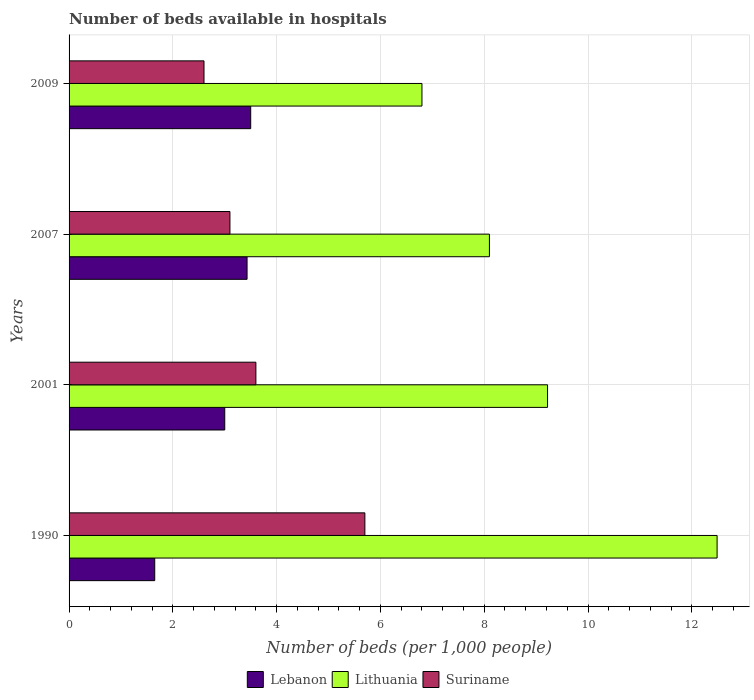How many different coloured bars are there?
Provide a short and direct response. 3. Are the number of bars per tick equal to the number of legend labels?
Your answer should be very brief. Yes. Are the number of bars on each tick of the Y-axis equal?
Offer a very short reply. Yes. How many bars are there on the 3rd tick from the top?
Offer a terse response. 3. What is the number of beds in the hospiatls of in Lebanon in 1990?
Your response must be concise. 1.65. Across all years, what is the maximum number of beds in the hospiatls of in Suriname?
Offer a very short reply. 5.7. Across all years, what is the minimum number of beds in the hospiatls of in Lebanon?
Ensure brevity in your answer.  1.65. In which year was the number of beds in the hospiatls of in Lithuania maximum?
Offer a very short reply. 1990. What is the total number of beds in the hospiatls of in Lebanon in the graph?
Make the answer very short. 11.58. What is the difference between the number of beds in the hospiatls of in Lithuania in 2001 and that in 2007?
Provide a succinct answer. 1.12. What is the difference between the number of beds in the hospiatls of in Lithuania in 1990 and the number of beds in the hospiatls of in Lebanon in 2001?
Make the answer very short. 9.49. What is the average number of beds in the hospiatls of in Lithuania per year?
Offer a terse response. 9.15. In the year 2007, what is the difference between the number of beds in the hospiatls of in Suriname and number of beds in the hospiatls of in Lebanon?
Your response must be concise. -0.33. In how many years, is the number of beds in the hospiatls of in Lebanon greater than 2.8 ?
Offer a very short reply. 3. What is the ratio of the number of beds in the hospiatls of in Lebanon in 2007 to that in 2009?
Give a very brief answer. 0.98. Is the number of beds in the hospiatls of in Lebanon in 2001 less than that in 2007?
Provide a short and direct response. Yes. Is the difference between the number of beds in the hospiatls of in Suriname in 1990 and 2001 greater than the difference between the number of beds in the hospiatls of in Lebanon in 1990 and 2001?
Your response must be concise. Yes. What is the difference between the highest and the second highest number of beds in the hospiatls of in Suriname?
Offer a terse response. 2.1. What is the difference between the highest and the lowest number of beds in the hospiatls of in Lebanon?
Offer a very short reply. 1.85. In how many years, is the number of beds in the hospiatls of in Lebanon greater than the average number of beds in the hospiatls of in Lebanon taken over all years?
Your answer should be very brief. 3. What does the 2nd bar from the top in 1990 represents?
Your answer should be compact. Lithuania. What does the 3rd bar from the bottom in 1990 represents?
Ensure brevity in your answer.  Suriname. Are all the bars in the graph horizontal?
Offer a very short reply. Yes. How many years are there in the graph?
Offer a terse response. 4. What is the difference between two consecutive major ticks on the X-axis?
Your answer should be very brief. 2. Does the graph contain any zero values?
Give a very brief answer. No. Does the graph contain grids?
Give a very brief answer. Yes. Where does the legend appear in the graph?
Make the answer very short. Bottom center. How many legend labels are there?
Your answer should be very brief. 3. How are the legend labels stacked?
Your response must be concise. Horizontal. What is the title of the graph?
Provide a short and direct response. Number of beds available in hospitals. Does "Bermuda" appear as one of the legend labels in the graph?
Make the answer very short. No. What is the label or title of the X-axis?
Your response must be concise. Number of beds (per 1,0 people). What is the Number of beds (per 1,000 people) of Lebanon in 1990?
Offer a very short reply. 1.65. What is the Number of beds (per 1,000 people) of Lithuania in 1990?
Your answer should be very brief. 12.49. What is the Number of beds (per 1,000 people) of Suriname in 1990?
Give a very brief answer. 5.7. What is the Number of beds (per 1,000 people) of Lebanon in 2001?
Make the answer very short. 3. What is the Number of beds (per 1,000 people) of Lithuania in 2001?
Keep it short and to the point. 9.22. What is the Number of beds (per 1,000 people) in Suriname in 2001?
Your response must be concise. 3.6. What is the Number of beds (per 1,000 people) of Lebanon in 2007?
Keep it short and to the point. 3.43. Across all years, what is the maximum Number of beds (per 1,000 people) in Lebanon?
Offer a terse response. 3.5. Across all years, what is the maximum Number of beds (per 1,000 people) in Lithuania?
Make the answer very short. 12.49. Across all years, what is the maximum Number of beds (per 1,000 people) in Suriname?
Your answer should be very brief. 5.7. Across all years, what is the minimum Number of beds (per 1,000 people) in Lebanon?
Your answer should be very brief. 1.65. Across all years, what is the minimum Number of beds (per 1,000 people) in Lithuania?
Ensure brevity in your answer.  6.8. Across all years, what is the minimum Number of beds (per 1,000 people) of Suriname?
Make the answer very short. 2.6. What is the total Number of beds (per 1,000 people) in Lebanon in the graph?
Make the answer very short. 11.58. What is the total Number of beds (per 1,000 people) of Lithuania in the graph?
Give a very brief answer. 36.61. What is the total Number of beds (per 1,000 people) in Suriname in the graph?
Your answer should be compact. 15. What is the difference between the Number of beds (per 1,000 people) of Lebanon in 1990 and that in 2001?
Your response must be concise. -1.35. What is the difference between the Number of beds (per 1,000 people) of Lithuania in 1990 and that in 2001?
Your response must be concise. 3.27. What is the difference between the Number of beds (per 1,000 people) of Lebanon in 1990 and that in 2007?
Provide a short and direct response. -1.78. What is the difference between the Number of beds (per 1,000 people) in Lithuania in 1990 and that in 2007?
Offer a very short reply. 4.39. What is the difference between the Number of beds (per 1,000 people) in Lebanon in 1990 and that in 2009?
Make the answer very short. -1.85. What is the difference between the Number of beds (per 1,000 people) in Lithuania in 1990 and that in 2009?
Offer a very short reply. 5.69. What is the difference between the Number of beds (per 1,000 people) in Suriname in 1990 and that in 2009?
Your response must be concise. 3.1. What is the difference between the Number of beds (per 1,000 people) of Lebanon in 2001 and that in 2007?
Offer a very short reply. -0.43. What is the difference between the Number of beds (per 1,000 people) in Lithuania in 2001 and that in 2007?
Your answer should be compact. 1.12. What is the difference between the Number of beds (per 1,000 people) of Lithuania in 2001 and that in 2009?
Offer a terse response. 2.42. What is the difference between the Number of beds (per 1,000 people) in Lebanon in 2007 and that in 2009?
Keep it short and to the point. -0.07. What is the difference between the Number of beds (per 1,000 people) in Lithuania in 2007 and that in 2009?
Keep it short and to the point. 1.3. What is the difference between the Number of beds (per 1,000 people) in Suriname in 2007 and that in 2009?
Ensure brevity in your answer.  0.5. What is the difference between the Number of beds (per 1,000 people) of Lebanon in 1990 and the Number of beds (per 1,000 people) of Lithuania in 2001?
Your answer should be compact. -7.57. What is the difference between the Number of beds (per 1,000 people) of Lebanon in 1990 and the Number of beds (per 1,000 people) of Suriname in 2001?
Offer a very short reply. -1.95. What is the difference between the Number of beds (per 1,000 people) of Lithuania in 1990 and the Number of beds (per 1,000 people) of Suriname in 2001?
Provide a short and direct response. 8.89. What is the difference between the Number of beds (per 1,000 people) in Lebanon in 1990 and the Number of beds (per 1,000 people) in Lithuania in 2007?
Your response must be concise. -6.45. What is the difference between the Number of beds (per 1,000 people) in Lebanon in 1990 and the Number of beds (per 1,000 people) in Suriname in 2007?
Your response must be concise. -1.45. What is the difference between the Number of beds (per 1,000 people) of Lithuania in 1990 and the Number of beds (per 1,000 people) of Suriname in 2007?
Offer a very short reply. 9.39. What is the difference between the Number of beds (per 1,000 people) of Lebanon in 1990 and the Number of beds (per 1,000 people) of Lithuania in 2009?
Your response must be concise. -5.15. What is the difference between the Number of beds (per 1,000 people) in Lebanon in 1990 and the Number of beds (per 1,000 people) in Suriname in 2009?
Provide a succinct answer. -0.95. What is the difference between the Number of beds (per 1,000 people) of Lithuania in 1990 and the Number of beds (per 1,000 people) of Suriname in 2009?
Keep it short and to the point. 9.89. What is the difference between the Number of beds (per 1,000 people) of Lebanon in 2001 and the Number of beds (per 1,000 people) of Suriname in 2007?
Make the answer very short. -0.1. What is the difference between the Number of beds (per 1,000 people) of Lithuania in 2001 and the Number of beds (per 1,000 people) of Suriname in 2007?
Your response must be concise. 6.12. What is the difference between the Number of beds (per 1,000 people) in Lebanon in 2001 and the Number of beds (per 1,000 people) in Lithuania in 2009?
Ensure brevity in your answer.  -3.8. What is the difference between the Number of beds (per 1,000 people) of Lebanon in 2001 and the Number of beds (per 1,000 people) of Suriname in 2009?
Offer a terse response. 0.4. What is the difference between the Number of beds (per 1,000 people) in Lithuania in 2001 and the Number of beds (per 1,000 people) in Suriname in 2009?
Provide a short and direct response. 6.62. What is the difference between the Number of beds (per 1,000 people) of Lebanon in 2007 and the Number of beds (per 1,000 people) of Lithuania in 2009?
Provide a succinct answer. -3.37. What is the difference between the Number of beds (per 1,000 people) in Lebanon in 2007 and the Number of beds (per 1,000 people) in Suriname in 2009?
Offer a very short reply. 0.83. What is the average Number of beds (per 1,000 people) of Lebanon per year?
Provide a short and direct response. 2.9. What is the average Number of beds (per 1,000 people) in Lithuania per year?
Provide a short and direct response. 9.15. What is the average Number of beds (per 1,000 people) of Suriname per year?
Provide a short and direct response. 3.75. In the year 1990, what is the difference between the Number of beds (per 1,000 people) in Lebanon and Number of beds (per 1,000 people) in Lithuania?
Make the answer very short. -10.84. In the year 1990, what is the difference between the Number of beds (per 1,000 people) of Lebanon and Number of beds (per 1,000 people) of Suriname?
Ensure brevity in your answer.  -4.05. In the year 1990, what is the difference between the Number of beds (per 1,000 people) in Lithuania and Number of beds (per 1,000 people) in Suriname?
Your answer should be very brief. 6.79. In the year 2001, what is the difference between the Number of beds (per 1,000 people) in Lebanon and Number of beds (per 1,000 people) in Lithuania?
Offer a very short reply. -6.22. In the year 2001, what is the difference between the Number of beds (per 1,000 people) of Lithuania and Number of beds (per 1,000 people) of Suriname?
Provide a succinct answer. 5.62. In the year 2007, what is the difference between the Number of beds (per 1,000 people) in Lebanon and Number of beds (per 1,000 people) in Lithuania?
Give a very brief answer. -4.67. In the year 2007, what is the difference between the Number of beds (per 1,000 people) of Lebanon and Number of beds (per 1,000 people) of Suriname?
Your response must be concise. 0.33. In the year 2007, what is the difference between the Number of beds (per 1,000 people) in Lithuania and Number of beds (per 1,000 people) in Suriname?
Offer a very short reply. 5. In the year 2009, what is the difference between the Number of beds (per 1,000 people) of Lebanon and Number of beds (per 1,000 people) of Lithuania?
Make the answer very short. -3.3. What is the ratio of the Number of beds (per 1,000 people) of Lebanon in 1990 to that in 2001?
Make the answer very short. 0.55. What is the ratio of the Number of beds (per 1,000 people) in Lithuania in 1990 to that in 2001?
Ensure brevity in your answer.  1.35. What is the ratio of the Number of beds (per 1,000 people) in Suriname in 1990 to that in 2001?
Your response must be concise. 1.58. What is the ratio of the Number of beds (per 1,000 people) of Lebanon in 1990 to that in 2007?
Provide a succinct answer. 0.48. What is the ratio of the Number of beds (per 1,000 people) in Lithuania in 1990 to that in 2007?
Your answer should be very brief. 1.54. What is the ratio of the Number of beds (per 1,000 people) in Suriname in 1990 to that in 2007?
Offer a terse response. 1.84. What is the ratio of the Number of beds (per 1,000 people) of Lebanon in 1990 to that in 2009?
Your answer should be very brief. 0.47. What is the ratio of the Number of beds (per 1,000 people) of Lithuania in 1990 to that in 2009?
Make the answer very short. 1.84. What is the ratio of the Number of beds (per 1,000 people) in Suriname in 1990 to that in 2009?
Provide a succinct answer. 2.19. What is the ratio of the Number of beds (per 1,000 people) in Lebanon in 2001 to that in 2007?
Keep it short and to the point. 0.87. What is the ratio of the Number of beds (per 1,000 people) in Lithuania in 2001 to that in 2007?
Your answer should be compact. 1.14. What is the ratio of the Number of beds (per 1,000 people) in Suriname in 2001 to that in 2007?
Your response must be concise. 1.16. What is the ratio of the Number of beds (per 1,000 people) in Lithuania in 2001 to that in 2009?
Provide a short and direct response. 1.36. What is the ratio of the Number of beds (per 1,000 people) of Suriname in 2001 to that in 2009?
Your response must be concise. 1.38. What is the ratio of the Number of beds (per 1,000 people) in Lithuania in 2007 to that in 2009?
Make the answer very short. 1.19. What is the ratio of the Number of beds (per 1,000 people) of Suriname in 2007 to that in 2009?
Make the answer very short. 1.19. What is the difference between the highest and the second highest Number of beds (per 1,000 people) of Lebanon?
Provide a short and direct response. 0.07. What is the difference between the highest and the second highest Number of beds (per 1,000 people) in Lithuania?
Offer a very short reply. 3.27. What is the difference between the highest and the second highest Number of beds (per 1,000 people) of Suriname?
Offer a terse response. 2.1. What is the difference between the highest and the lowest Number of beds (per 1,000 people) of Lebanon?
Your answer should be compact. 1.85. What is the difference between the highest and the lowest Number of beds (per 1,000 people) of Lithuania?
Give a very brief answer. 5.69. What is the difference between the highest and the lowest Number of beds (per 1,000 people) in Suriname?
Your answer should be very brief. 3.1. 